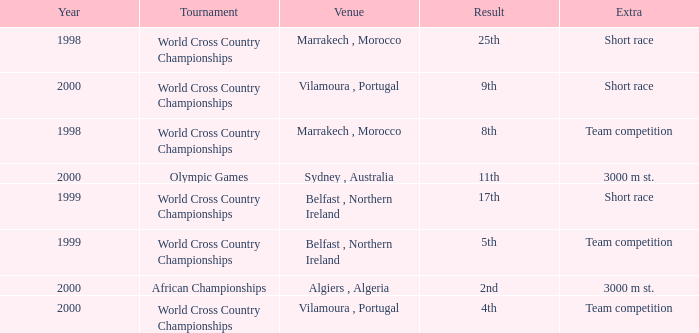Tell me the venue for extra of short race and year less than 1999 Marrakech , Morocco. 